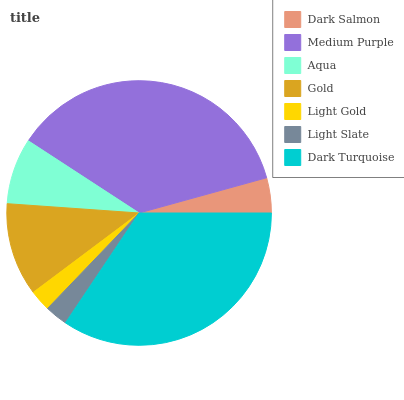Is Light Gold the minimum?
Answer yes or no. Yes. Is Medium Purple the maximum?
Answer yes or no. Yes. Is Aqua the minimum?
Answer yes or no. No. Is Aqua the maximum?
Answer yes or no. No. Is Medium Purple greater than Aqua?
Answer yes or no. Yes. Is Aqua less than Medium Purple?
Answer yes or no. Yes. Is Aqua greater than Medium Purple?
Answer yes or no. No. Is Medium Purple less than Aqua?
Answer yes or no. No. Is Aqua the high median?
Answer yes or no. Yes. Is Aqua the low median?
Answer yes or no. Yes. Is Gold the high median?
Answer yes or no. No. Is Light Gold the low median?
Answer yes or no. No. 